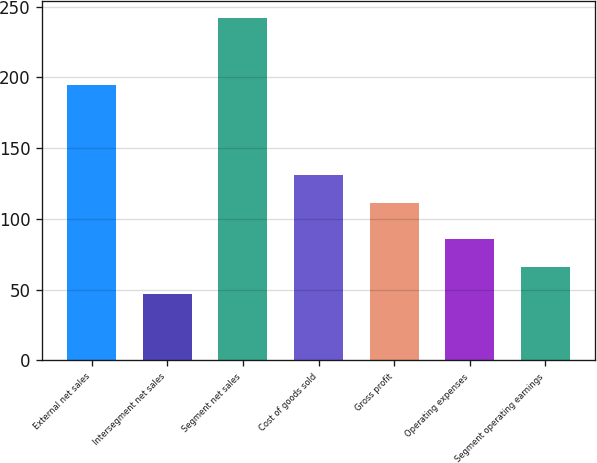Convert chart to OTSL. <chart><loc_0><loc_0><loc_500><loc_500><bar_chart><fcel>External net sales<fcel>Intersegment net sales<fcel>Segment net sales<fcel>Cost of goods sold<fcel>Gross profit<fcel>Operating expenses<fcel>Segment operating earnings<nl><fcel>194.8<fcel>46.8<fcel>241.6<fcel>130.68<fcel>111.2<fcel>85.76<fcel>66.28<nl></chart> 